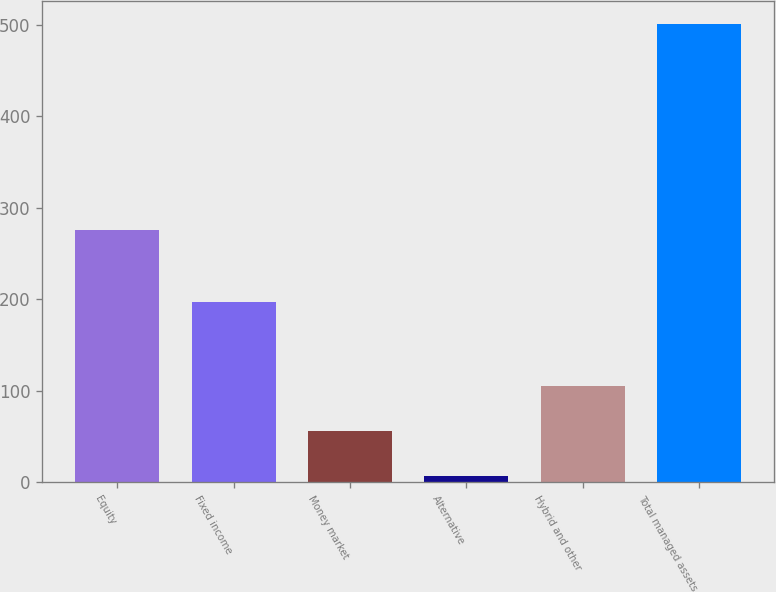Convert chart. <chart><loc_0><loc_0><loc_500><loc_500><bar_chart><fcel>Equity<fcel>Fixed income<fcel>Money market<fcel>Alternative<fcel>Hybrid and other<fcel>Total managed assets<nl><fcel>275.3<fcel>196.4<fcel>55.84<fcel>6.4<fcel>105.28<fcel>500.8<nl></chart> 